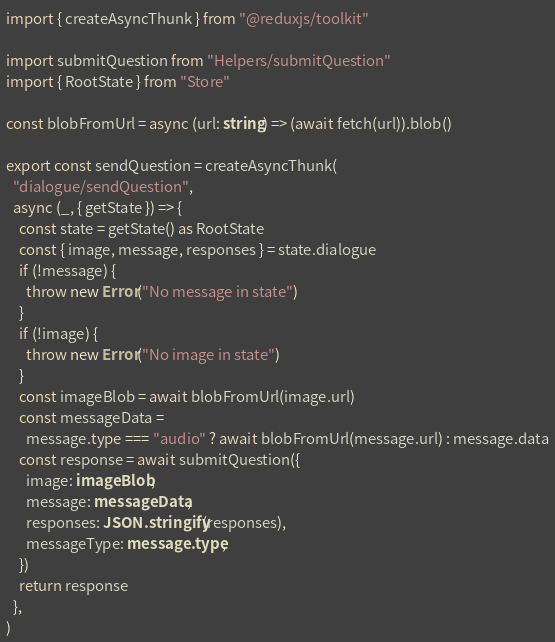Convert code to text. <code><loc_0><loc_0><loc_500><loc_500><_TypeScript_>import { createAsyncThunk } from "@reduxjs/toolkit"

import submitQuestion from "Helpers/submitQuestion"
import { RootState } from "Store"

const blobFromUrl = async (url: string) => (await fetch(url)).blob()

export const sendQuestion = createAsyncThunk(
  "dialogue/sendQuestion",
  async (_, { getState }) => {
    const state = getState() as RootState
    const { image, message, responses } = state.dialogue
    if (!message) {
      throw new Error("No message in state")
    }
    if (!image) {
      throw new Error("No image in state")
    }
    const imageBlob = await blobFromUrl(image.url)
    const messageData =
      message.type === "audio" ? await blobFromUrl(message.url) : message.data
    const response = await submitQuestion({
      image: imageBlob,
      message: messageData,
      responses: JSON.stringify(responses),
      messageType: message.type,
    })
    return response
  },
)
</code> 